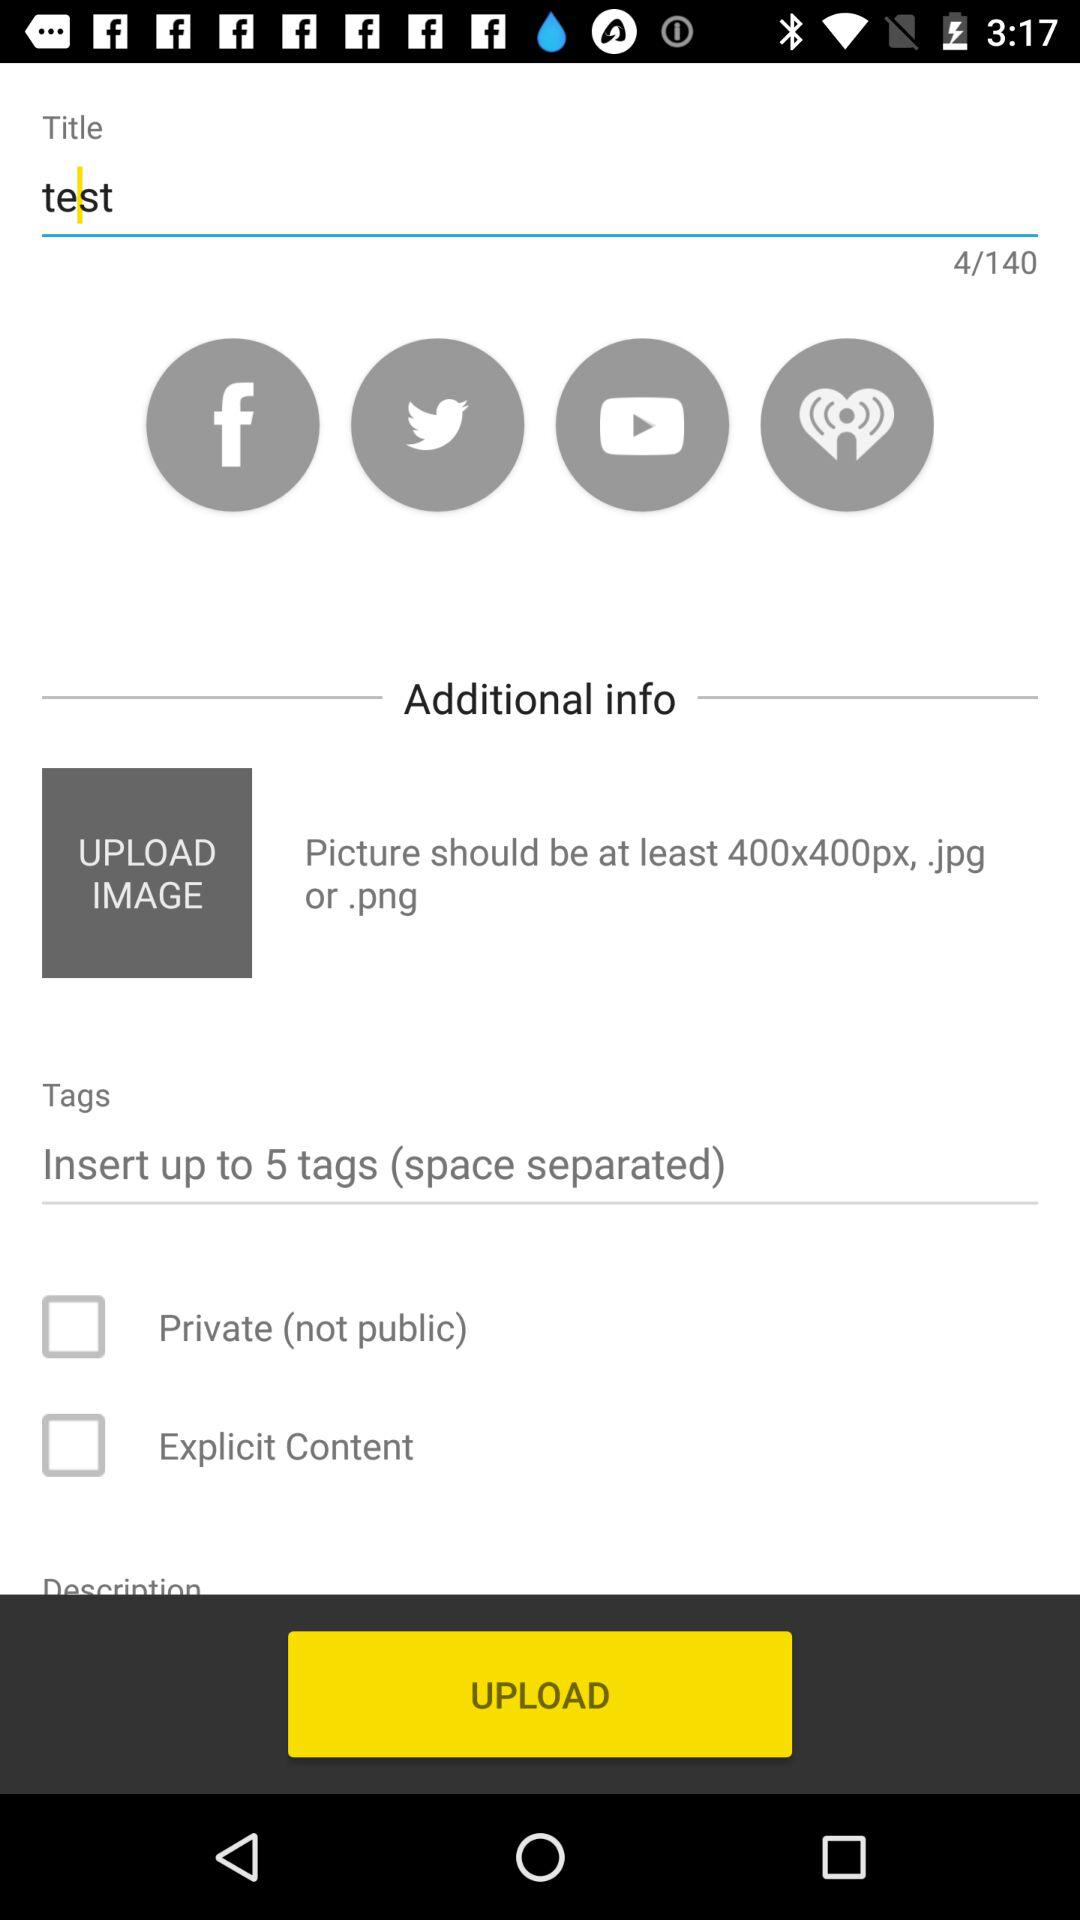How many tags can be inserted into the tags field?
Answer the question using a single word or phrase. 5 